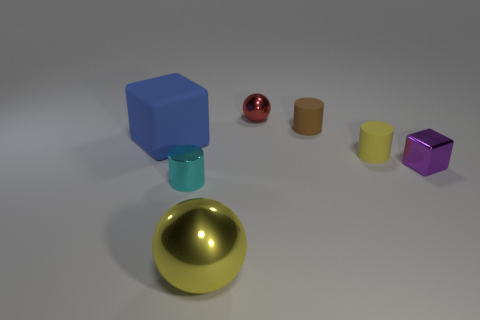Subtract all tiny cyan cylinders. How many cylinders are left? 2 Subtract all yellow balls. How many balls are left? 1 Subtract all brown balls. Subtract all purple cylinders. How many balls are left? 2 Add 2 tiny red balls. How many objects exist? 9 Subtract 2 cylinders. How many cylinders are left? 1 Add 7 blue objects. How many blue objects are left? 8 Add 3 small yellow cylinders. How many small yellow cylinders exist? 4 Subtract 1 purple blocks. How many objects are left? 6 Subtract all balls. How many objects are left? 5 Subtract all cyan balls. How many yellow cylinders are left? 1 